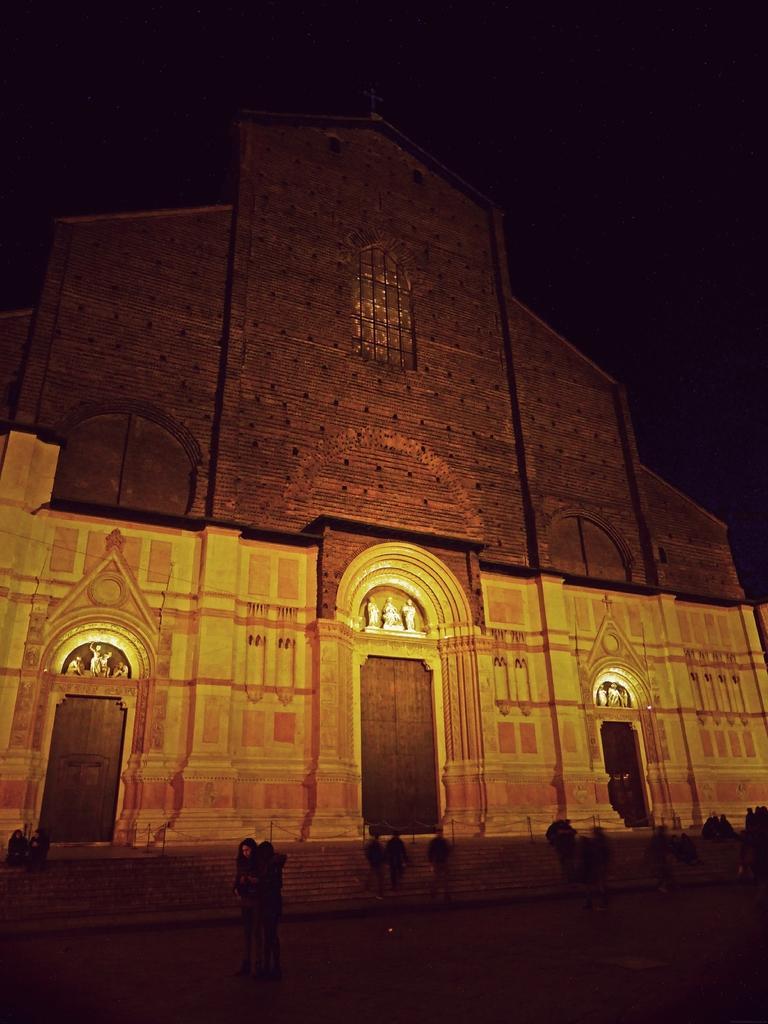How would you summarize this image in a sentence or two? This image is taken during night time. In the background there is a monument. There are also few people. Stairs are also visible. 